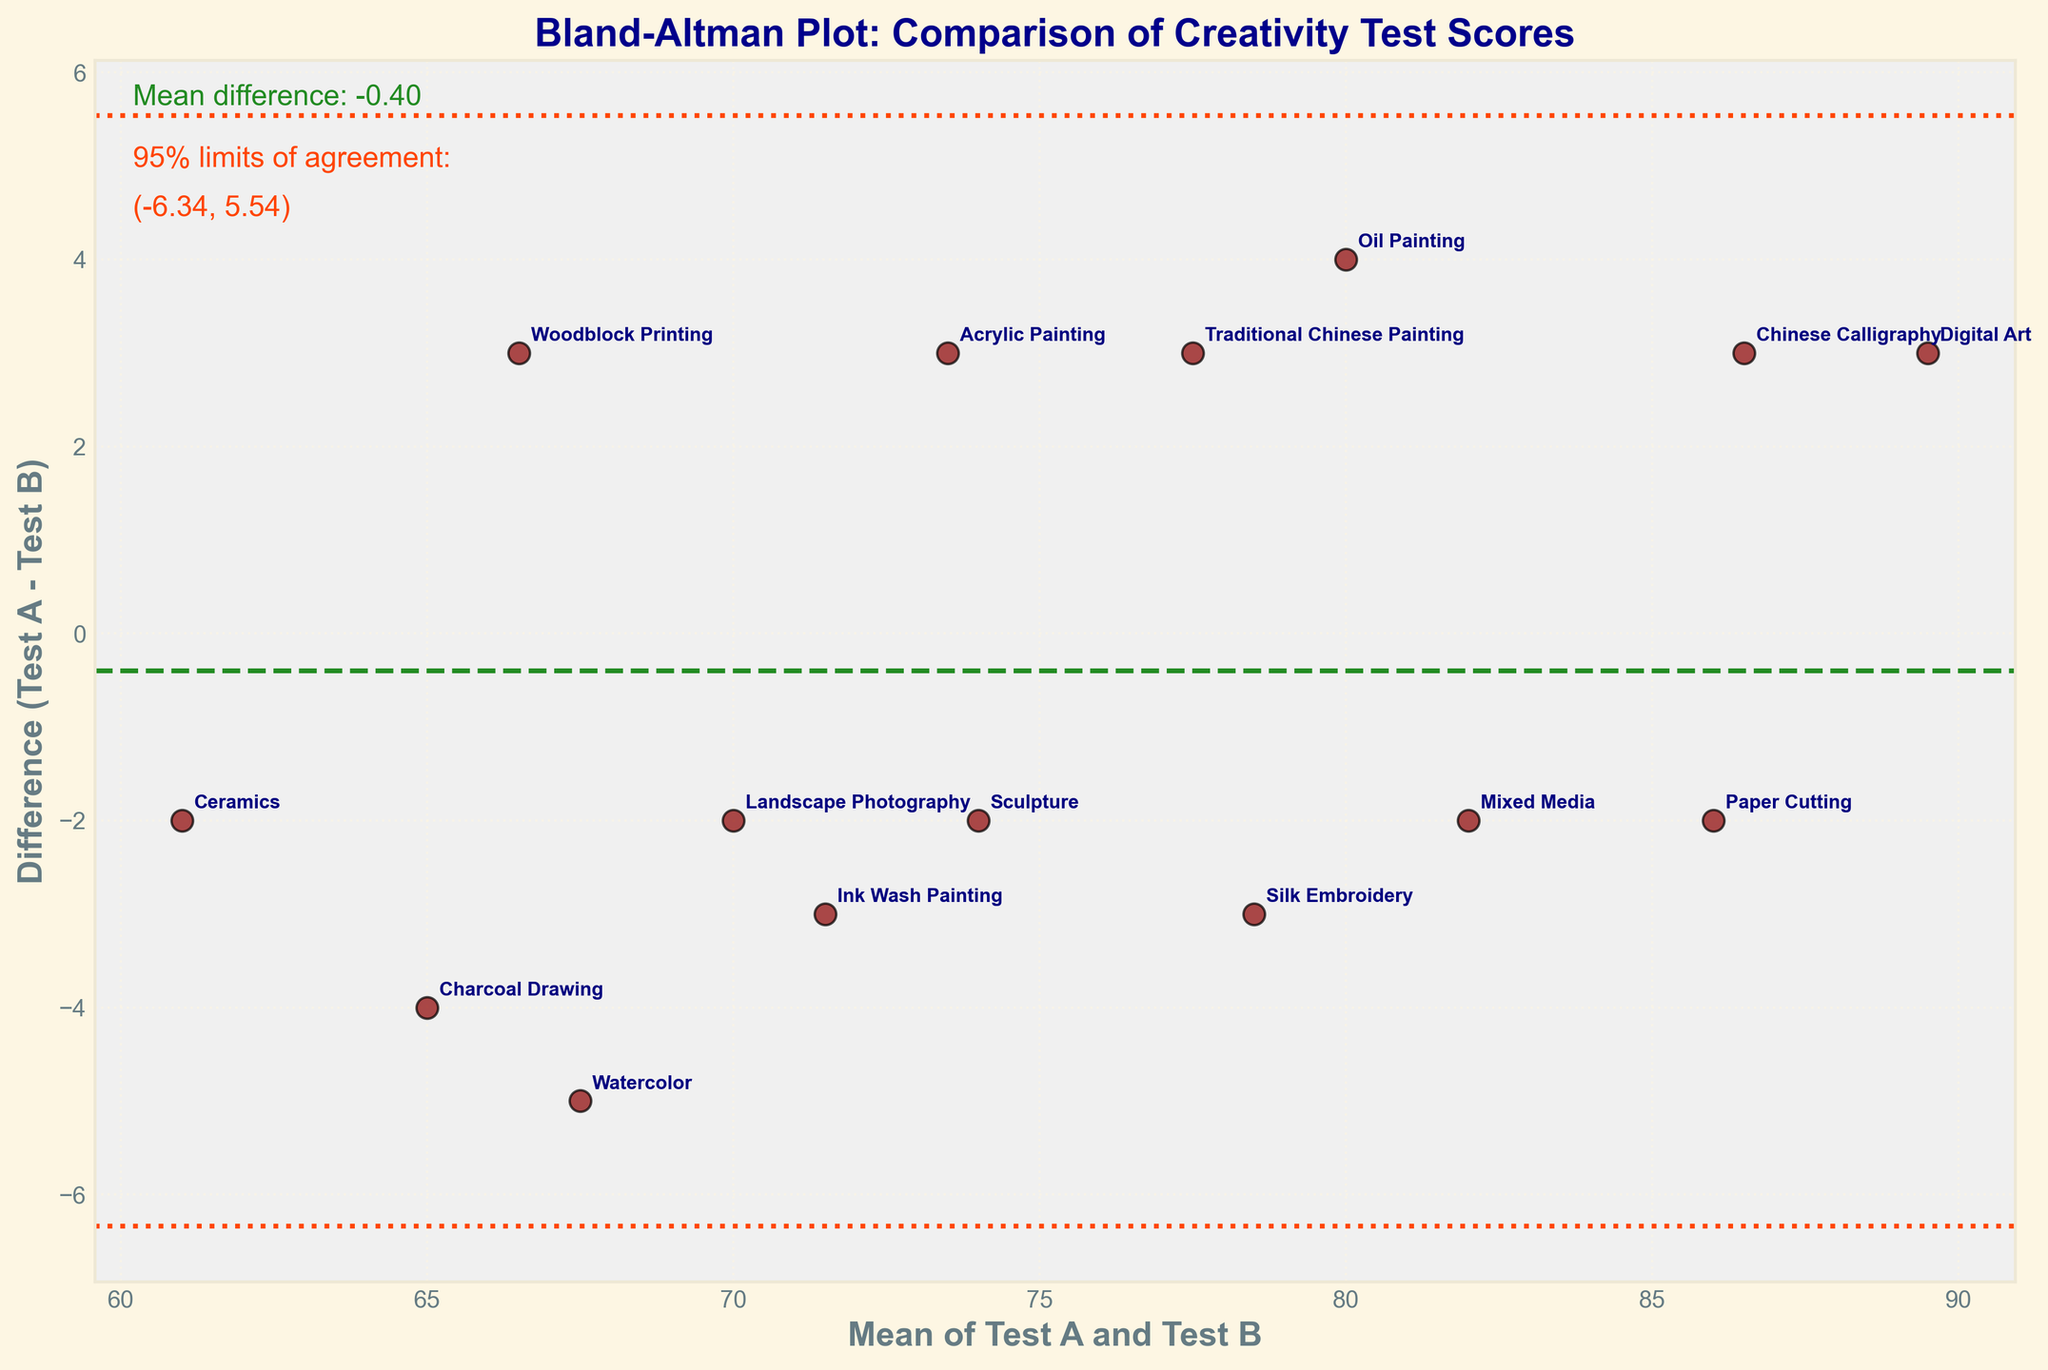What is the title of the plot? The title of the plot is displayed at the very top and reads: "Bland-Altman Plot: Comparison of Creativity Test Scores."
Answer: Bland-Altman Plot: Comparison of Creativity Test Scores How many data points are plotted in the figure? Each data point corresponds to a medium's creativity score differences between Test A and Test B. By counting the number of scatter points or annotations, we can find there are 15 data points.
Answer: 15 What score difference does Oil Painting have between Test A and Test B? Look for the "Oil Painting" annotation and check its corresponding y-axis value which indicates the difference. The difference for Oil Painting is 4 (since Test A score is 82 and Test B score is 78).
Answer: 4 Which artistic medium has the highest mean score between Test A and Test B? Identify the highest point on the x-axis (mean scores). The annotation at this highest point is "Digital Art."
Answer: Digital Art What is the mean difference line value in the plot? The mean difference (md) line is the horizontal green dashed line in the plot. As per the text annotation in the figure, the mean difference is displayed near the top left as approximately 0.53.
Answer: approx. 0.53 Describe the two red dashed lines in the plot and what they represent. These lines are the 95% limits of agreement, calculated as mean difference ± 1.96 times the standard deviation of the differences. The specific values are annotated on the figure as (md - 1.96*sd, md + 1.96*sd) which approximate to (-4.60, 5.66).
Answer: 95% limits of agreement, approx. -4.60 and 5.66 Which two artistic mediums have differences with opposite signs (one above and one below the mean difference line)? Check for annotations above and below the mean difference line. "Oil Painting" is above (positive difference) while "Watercolor" is below (negative difference).
Answer: Oil Painting and Watercolor What can you infer if most points fall within the 95% limits of agreement? If most points fall within the 95% limits of agreement, it suggests that the two tests have good agreement for evaluating student's creativity scores.
Answer: Good agreement What does it mean if a point lies outside the 95% limits of agreement? An outlier point outside the 95% limits suggests inconsistency between Test A and Test B for that specific medium, indicating large discrepancies in creativity scores.
Answer: Inconsistency How does the plot indicate the reliability of Test A compared to Test B? By analyzing the mean difference and 95% limits, if the mean difference is close to zero and most points lie within the agreement limits, it suggests that Test A and Test B have consistent measurements and thus reliable comparison.
Answer: Consistent measurements 